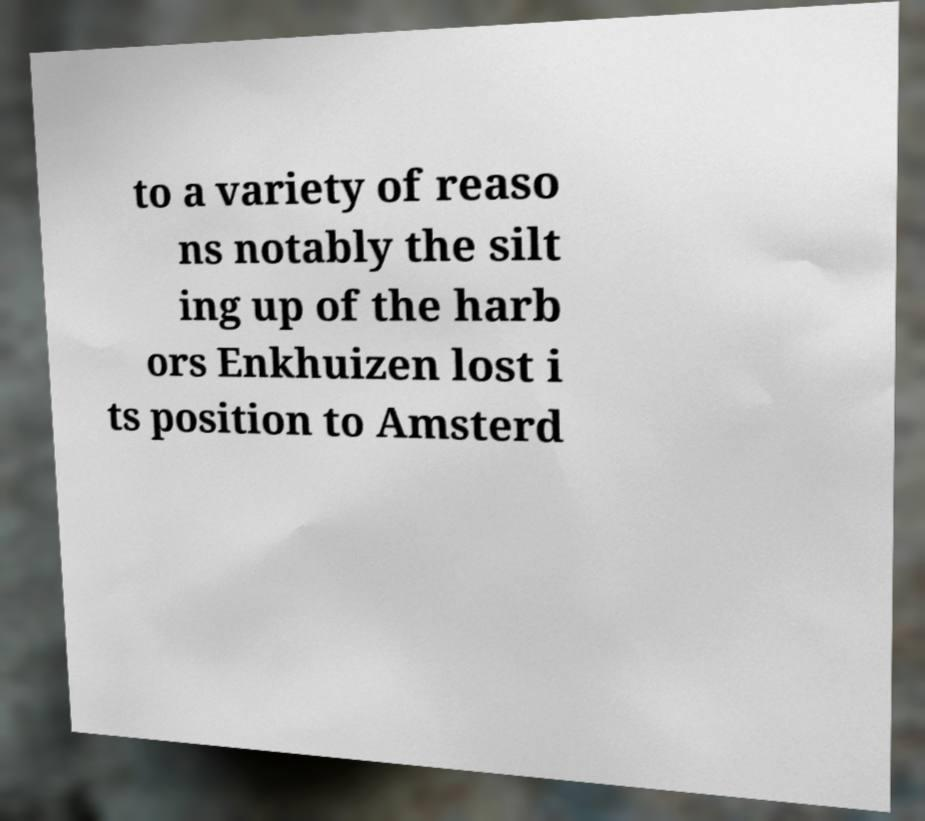For documentation purposes, I need the text within this image transcribed. Could you provide that? to a variety of reaso ns notably the silt ing up of the harb ors Enkhuizen lost i ts position to Amsterd 